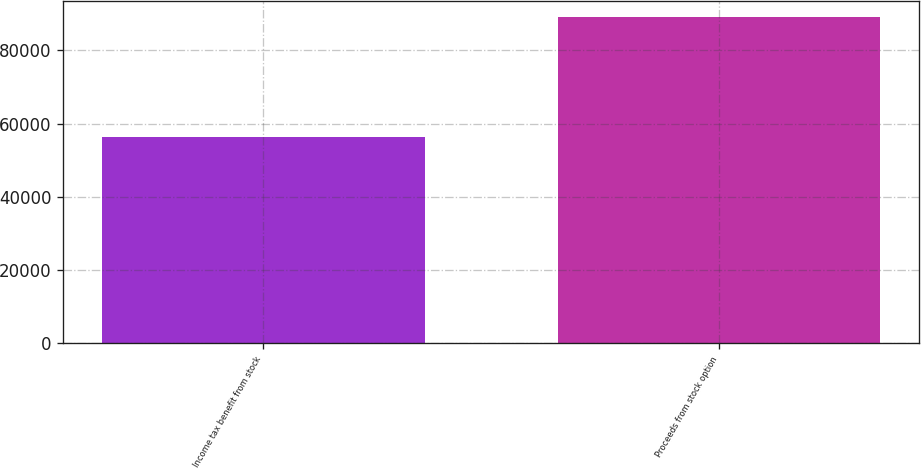Convert chart to OTSL. <chart><loc_0><loc_0><loc_500><loc_500><bar_chart><fcel>Income tax benefit from stock<fcel>Proceeds from stock option<nl><fcel>56351<fcel>89113<nl></chart> 